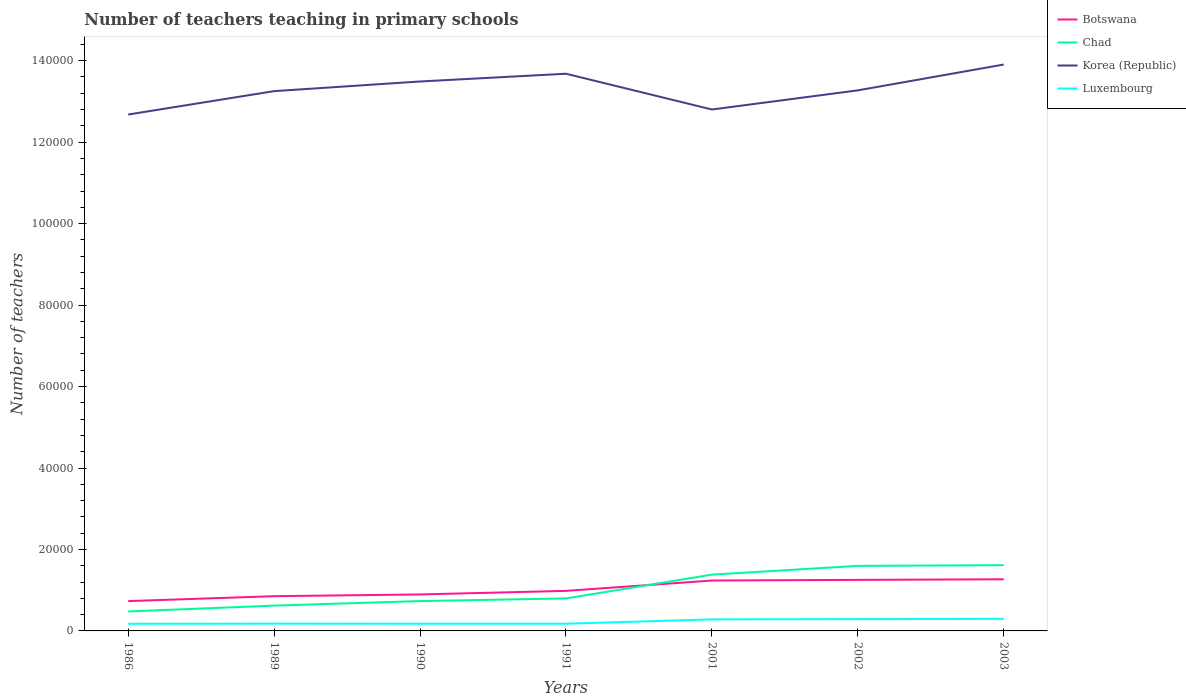How many different coloured lines are there?
Your answer should be compact. 4. Across all years, what is the maximum number of teachers teaching in primary schools in Luxembourg?
Keep it short and to the point. 1745. What is the total number of teachers teaching in primary schools in Korea (Republic) in the graph?
Your answer should be very brief. -2257. What is the difference between the highest and the second highest number of teachers teaching in primary schools in Korea (Republic)?
Ensure brevity in your answer.  1.23e+04. What is the difference between the highest and the lowest number of teachers teaching in primary schools in Korea (Republic)?
Your answer should be very brief. 3. Is the number of teachers teaching in primary schools in Chad strictly greater than the number of teachers teaching in primary schools in Botswana over the years?
Offer a terse response. No. How many years are there in the graph?
Your answer should be very brief. 7. What is the difference between two consecutive major ticks on the Y-axis?
Give a very brief answer. 2.00e+04. Where does the legend appear in the graph?
Make the answer very short. Top right. How many legend labels are there?
Your response must be concise. 4. How are the legend labels stacked?
Ensure brevity in your answer.  Vertical. What is the title of the graph?
Keep it short and to the point. Number of teachers teaching in primary schools. Does "Upper middle income" appear as one of the legend labels in the graph?
Your answer should be very brief. No. What is the label or title of the Y-axis?
Offer a terse response. Number of teachers. What is the Number of teachers in Botswana in 1986?
Offer a terse response. 7324. What is the Number of teachers of Chad in 1986?
Your response must be concise. 4779. What is the Number of teachers of Korea (Republic) in 1986?
Provide a short and direct response. 1.27e+05. What is the Number of teachers of Luxembourg in 1986?
Keep it short and to the point. 1745. What is the Number of teachers in Botswana in 1989?
Your answer should be very brief. 8529. What is the Number of teachers in Chad in 1989?
Offer a terse response. 6215. What is the Number of teachers in Korea (Republic) in 1989?
Give a very brief answer. 1.33e+05. What is the Number of teachers in Luxembourg in 1989?
Provide a succinct answer. 1790. What is the Number of teachers of Botswana in 1990?
Make the answer very short. 8956. What is the Number of teachers of Chad in 1990?
Give a very brief answer. 7327. What is the Number of teachers of Korea (Republic) in 1990?
Your answer should be compact. 1.35e+05. What is the Number of teachers of Luxembourg in 1990?
Keep it short and to the point. 1770. What is the Number of teachers in Botswana in 1991?
Make the answer very short. 9833. What is the Number of teachers in Chad in 1991?
Provide a succinct answer. 7980. What is the Number of teachers in Korea (Republic) in 1991?
Ensure brevity in your answer.  1.37e+05. What is the Number of teachers of Luxembourg in 1991?
Give a very brief answer. 1764. What is the Number of teachers of Botswana in 2001?
Provide a succinct answer. 1.24e+04. What is the Number of teachers of Chad in 2001?
Your response must be concise. 1.38e+04. What is the Number of teachers in Korea (Republic) in 2001?
Offer a very short reply. 1.28e+05. What is the Number of teachers in Luxembourg in 2001?
Your answer should be very brief. 2834. What is the Number of teachers of Botswana in 2002?
Your answer should be very brief. 1.25e+04. What is the Number of teachers in Chad in 2002?
Give a very brief answer. 1.60e+04. What is the Number of teachers of Korea (Republic) in 2002?
Your response must be concise. 1.33e+05. What is the Number of teachers of Luxembourg in 2002?
Offer a very short reply. 2893. What is the Number of teachers in Botswana in 2003?
Make the answer very short. 1.27e+04. What is the Number of teachers of Chad in 2003?
Your answer should be compact. 1.61e+04. What is the Number of teachers in Korea (Republic) in 2003?
Offer a very short reply. 1.39e+05. What is the Number of teachers of Luxembourg in 2003?
Make the answer very short. 2966. Across all years, what is the maximum Number of teachers of Botswana?
Your answer should be very brief. 1.27e+04. Across all years, what is the maximum Number of teachers of Chad?
Give a very brief answer. 1.61e+04. Across all years, what is the maximum Number of teachers in Korea (Republic)?
Your response must be concise. 1.39e+05. Across all years, what is the maximum Number of teachers in Luxembourg?
Keep it short and to the point. 2966. Across all years, what is the minimum Number of teachers in Botswana?
Your answer should be very brief. 7324. Across all years, what is the minimum Number of teachers in Chad?
Give a very brief answer. 4779. Across all years, what is the minimum Number of teachers in Korea (Republic)?
Keep it short and to the point. 1.27e+05. Across all years, what is the minimum Number of teachers of Luxembourg?
Provide a short and direct response. 1745. What is the total Number of teachers of Botswana in the graph?
Provide a succinct answer. 7.22e+04. What is the total Number of teachers of Chad in the graph?
Give a very brief answer. 7.22e+04. What is the total Number of teachers of Korea (Republic) in the graph?
Your answer should be very brief. 9.31e+05. What is the total Number of teachers in Luxembourg in the graph?
Your answer should be compact. 1.58e+04. What is the difference between the Number of teachers of Botswana in 1986 and that in 1989?
Keep it short and to the point. -1205. What is the difference between the Number of teachers in Chad in 1986 and that in 1989?
Your answer should be very brief. -1436. What is the difference between the Number of teachers of Korea (Republic) in 1986 and that in 1989?
Keep it short and to the point. -5742. What is the difference between the Number of teachers in Luxembourg in 1986 and that in 1989?
Keep it short and to the point. -45. What is the difference between the Number of teachers of Botswana in 1986 and that in 1990?
Your response must be concise. -1632. What is the difference between the Number of teachers of Chad in 1986 and that in 1990?
Make the answer very short. -2548. What is the difference between the Number of teachers of Korea (Republic) in 1986 and that in 1990?
Provide a short and direct response. -8113. What is the difference between the Number of teachers of Luxembourg in 1986 and that in 1990?
Your response must be concise. -25. What is the difference between the Number of teachers of Botswana in 1986 and that in 1991?
Provide a short and direct response. -2509. What is the difference between the Number of teachers in Chad in 1986 and that in 1991?
Keep it short and to the point. -3201. What is the difference between the Number of teachers of Korea (Republic) in 1986 and that in 1991?
Provide a succinct answer. -1.00e+04. What is the difference between the Number of teachers of Botswana in 1986 and that in 2001?
Make the answer very short. -5046. What is the difference between the Number of teachers of Chad in 1986 and that in 2001?
Keep it short and to the point. -9040. What is the difference between the Number of teachers of Korea (Republic) in 1986 and that in 2001?
Your answer should be compact. -1233. What is the difference between the Number of teachers of Luxembourg in 1986 and that in 2001?
Your answer should be very brief. -1089. What is the difference between the Number of teachers of Botswana in 1986 and that in 2002?
Your response must be concise. -5207. What is the difference between the Number of teachers of Chad in 1986 and that in 2002?
Offer a very short reply. -1.12e+04. What is the difference between the Number of teachers in Korea (Republic) in 1986 and that in 2002?
Provide a succinct answer. -5931. What is the difference between the Number of teachers of Luxembourg in 1986 and that in 2002?
Provide a succinct answer. -1148. What is the difference between the Number of teachers of Botswana in 1986 and that in 2003?
Offer a terse response. -5354. What is the difference between the Number of teachers of Chad in 1986 and that in 2003?
Your answer should be compact. -1.14e+04. What is the difference between the Number of teachers in Korea (Republic) in 1986 and that in 2003?
Make the answer very short. -1.23e+04. What is the difference between the Number of teachers of Luxembourg in 1986 and that in 2003?
Your answer should be very brief. -1221. What is the difference between the Number of teachers of Botswana in 1989 and that in 1990?
Provide a short and direct response. -427. What is the difference between the Number of teachers in Chad in 1989 and that in 1990?
Your answer should be compact. -1112. What is the difference between the Number of teachers in Korea (Republic) in 1989 and that in 1990?
Offer a very short reply. -2371. What is the difference between the Number of teachers of Botswana in 1989 and that in 1991?
Give a very brief answer. -1304. What is the difference between the Number of teachers in Chad in 1989 and that in 1991?
Offer a very short reply. -1765. What is the difference between the Number of teachers in Korea (Republic) in 1989 and that in 1991?
Your answer should be compact. -4273. What is the difference between the Number of teachers of Botswana in 1989 and that in 2001?
Keep it short and to the point. -3841. What is the difference between the Number of teachers in Chad in 1989 and that in 2001?
Make the answer very short. -7604. What is the difference between the Number of teachers in Korea (Republic) in 1989 and that in 2001?
Keep it short and to the point. 4509. What is the difference between the Number of teachers of Luxembourg in 1989 and that in 2001?
Provide a short and direct response. -1044. What is the difference between the Number of teachers in Botswana in 1989 and that in 2002?
Offer a very short reply. -4002. What is the difference between the Number of teachers in Chad in 1989 and that in 2002?
Give a very brief answer. -9756. What is the difference between the Number of teachers of Korea (Republic) in 1989 and that in 2002?
Offer a terse response. -189. What is the difference between the Number of teachers in Luxembourg in 1989 and that in 2002?
Make the answer very short. -1103. What is the difference between the Number of teachers of Botswana in 1989 and that in 2003?
Your answer should be compact. -4149. What is the difference between the Number of teachers in Chad in 1989 and that in 2003?
Your answer should be very brief. -9927. What is the difference between the Number of teachers in Korea (Republic) in 1989 and that in 2003?
Offer a terse response. -6530. What is the difference between the Number of teachers in Luxembourg in 1989 and that in 2003?
Ensure brevity in your answer.  -1176. What is the difference between the Number of teachers in Botswana in 1990 and that in 1991?
Your answer should be compact. -877. What is the difference between the Number of teachers in Chad in 1990 and that in 1991?
Make the answer very short. -653. What is the difference between the Number of teachers of Korea (Republic) in 1990 and that in 1991?
Offer a very short reply. -1902. What is the difference between the Number of teachers in Luxembourg in 1990 and that in 1991?
Keep it short and to the point. 6. What is the difference between the Number of teachers in Botswana in 1990 and that in 2001?
Your answer should be very brief. -3414. What is the difference between the Number of teachers in Chad in 1990 and that in 2001?
Your answer should be compact. -6492. What is the difference between the Number of teachers in Korea (Republic) in 1990 and that in 2001?
Ensure brevity in your answer.  6880. What is the difference between the Number of teachers of Luxembourg in 1990 and that in 2001?
Ensure brevity in your answer.  -1064. What is the difference between the Number of teachers in Botswana in 1990 and that in 2002?
Your response must be concise. -3575. What is the difference between the Number of teachers of Chad in 1990 and that in 2002?
Your answer should be compact. -8644. What is the difference between the Number of teachers of Korea (Republic) in 1990 and that in 2002?
Provide a short and direct response. 2182. What is the difference between the Number of teachers in Luxembourg in 1990 and that in 2002?
Provide a succinct answer. -1123. What is the difference between the Number of teachers in Botswana in 1990 and that in 2003?
Make the answer very short. -3722. What is the difference between the Number of teachers of Chad in 1990 and that in 2003?
Provide a succinct answer. -8815. What is the difference between the Number of teachers in Korea (Republic) in 1990 and that in 2003?
Offer a very short reply. -4159. What is the difference between the Number of teachers of Luxembourg in 1990 and that in 2003?
Give a very brief answer. -1196. What is the difference between the Number of teachers of Botswana in 1991 and that in 2001?
Offer a terse response. -2537. What is the difference between the Number of teachers of Chad in 1991 and that in 2001?
Keep it short and to the point. -5839. What is the difference between the Number of teachers of Korea (Republic) in 1991 and that in 2001?
Provide a short and direct response. 8782. What is the difference between the Number of teachers of Luxembourg in 1991 and that in 2001?
Ensure brevity in your answer.  -1070. What is the difference between the Number of teachers in Botswana in 1991 and that in 2002?
Provide a succinct answer. -2698. What is the difference between the Number of teachers in Chad in 1991 and that in 2002?
Make the answer very short. -7991. What is the difference between the Number of teachers of Korea (Republic) in 1991 and that in 2002?
Your answer should be very brief. 4084. What is the difference between the Number of teachers in Luxembourg in 1991 and that in 2002?
Keep it short and to the point. -1129. What is the difference between the Number of teachers in Botswana in 1991 and that in 2003?
Your response must be concise. -2845. What is the difference between the Number of teachers in Chad in 1991 and that in 2003?
Your response must be concise. -8162. What is the difference between the Number of teachers in Korea (Republic) in 1991 and that in 2003?
Offer a very short reply. -2257. What is the difference between the Number of teachers of Luxembourg in 1991 and that in 2003?
Offer a terse response. -1202. What is the difference between the Number of teachers in Botswana in 2001 and that in 2002?
Make the answer very short. -161. What is the difference between the Number of teachers of Chad in 2001 and that in 2002?
Give a very brief answer. -2152. What is the difference between the Number of teachers in Korea (Republic) in 2001 and that in 2002?
Offer a very short reply. -4698. What is the difference between the Number of teachers of Luxembourg in 2001 and that in 2002?
Make the answer very short. -59. What is the difference between the Number of teachers in Botswana in 2001 and that in 2003?
Ensure brevity in your answer.  -308. What is the difference between the Number of teachers in Chad in 2001 and that in 2003?
Offer a very short reply. -2323. What is the difference between the Number of teachers in Korea (Republic) in 2001 and that in 2003?
Your response must be concise. -1.10e+04. What is the difference between the Number of teachers in Luxembourg in 2001 and that in 2003?
Make the answer very short. -132. What is the difference between the Number of teachers in Botswana in 2002 and that in 2003?
Give a very brief answer. -147. What is the difference between the Number of teachers of Chad in 2002 and that in 2003?
Make the answer very short. -171. What is the difference between the Number of teachers in Korea (Republic) in 2002 and that in 2003?
Your answer should be very brief. -6341. What is the difference between the Number of teachers of Luxembourg in 2002 and that in 2003?
Provide a succinct answer. -73. What is the difference between the Number of teachers of Botswana in 1986 and the Number of teachers of Chad in 1989?
Provide a short and direct response. 1109. What is the difference between the Number of teachers in Botswana in 1986 and the Number of teachers in Korea (Republic) in 1989?
Provide a succinct answer. -1.25e+05. What is the difference between the Number of teachers of Botswana in 1986 and the Number of teachers of Luxembourg in 1989?
Provide a succinct answer. 5534. What is the difference between the Number of teachers in Chad in 1986 and the Number of teachers in Korea (Republic) in 1989?
Provide a succinct answer. -1.28e+05. What is the difference between the Number of teachers of Chad in 1986 and the Number of teachers of Luxembourg in 1989?
Offer a very short reply. 2989. What is the difference between the Number of teachers of Korea (Republic) in 1986 and the Number of teachers of Luxembourg in 1989?
Offer a very short reply. 1.25e+05. What is the difference between the Number of teachers in Botswana in 1986 and the Number of teachers in Chad in 1990?
Keep it short and to the point. -3. What is the difference between the Number of teachers of Botswana in 1986 and the Number of teachers of Korea (Republic) in 1990?
Your response must be concise. -1.28e+05. What is the difference between the Number of teachers of Botswana in 1986 and the Number of teachers of Luxembourg in 1990?
Keep it short and to the point. 5554. What is the difference between the Number of teachers of Chad in 1986 and the Number of teachers of Korea (Republic) in 1990?
Offer a terse response. -1.30e+05. What is the difference between the Number of teachers of Chad in 1986 and the Number of teachers of Luxembourg in 1990?
Ensure brevity in your answer.  3009. What is the difference between the Number of teachers of Korea (Republic) in 1986 and the Number of teachers of Luxembourg in 1990?
Make the answer very short. 1.25e+05. What is the difference between the Number of teachers in Botswana in 1986 and the Number of teachers in Chad in 1991?
Ensure brevity in your answer.  -656. What is the difference between the Number of teachers of Botswana in 1986 and the Number of teachers of Korea (Republic) in 1991?
Provide a short and direct response. -1.29e+05. What is the difference between the Number of teachers of Botswana in 1986 and the Number of teachers of Luxembourg in 1991?
Offer a terse response. 5560. What is the difference between the Number of teachers in Chad in 1986 and the Number of teachers in Korea (Republic) in 1991?
Provide a succinct answer. -1.32e+05. What is the difference between the Number of teachers of Chad in 1986 and the Number of teachers of Luxembourg in 1991?
Ensure brevity in your answer.  3015. What is the difference between the Number of teachers of Korea (Republic) in 1986 and the Number of teachers of Luxembourg in 1991?
Your answer should be very brief. 1.25e+05. What is the difference between the Number of teachers in Botswana in 1986 and the Number of teachers in Chad in 2001?
Your answer should be very brief. -6495. What is the difference between the Number of teachers in Botswana in 1986 and the Number of teachers in Korea (Republic) in 2001?
Provide a short and direct response. -1.21e+05. What is the difference between the Number of teachers in Botswana in 1986 and the Number of teachers in Luxembourg in 2001?
Offer a terse response. 4490. What is the difference between the Number of teachers of Chad in 1986 and the Number of teachers of Korea (Republic) in 2001?
Give a very brief answer. -1.23e+05. What is the difference between the Number of teachers of Chad in 1986 and the Number of teachers of Luxembourg in 2001?
Offer a very short reply. 1945. What is the difference between the Number of teachers of Korea (Republic) in 1986 and the Number of teachers of Luxembourg in 2001?
Keep it short and to the point. 1.24e+05. What is the difference between the Number of teachers in Botswana in 1986 and the Number of teachers in Chad in 2002?
Keep it short and to the point. -8647. What is the difference between the Number of teachers in Botswana in 1986 and the Number of teachers in Korea (Republic) in 2002?
Make the answer very short. -1.25e+05. What is the difference between the Number of teachers in Botswana in 1986 and the Number of teachers in Luxembourg in 2002?
Ensure brevity in your answer.  4431. What is the difference between the Number of teachers in Chad in 1986 and the Number of teachers in Korea (Republic) in 2002?
Provide a succinct answer. -1.28e+05. What is the difference between the Number of teachers in Chad in 1986 and the Number of teachers in Luxembourg in 2002?
Your answer should be compact. 1886. What is the difference between the Number of teachers in Korea (Republic) in 1986 and the Number of teachers in Luxembourg in 2002?
Your answer should be very brief. 1.24e+05. What is the difference between the Number of teachers in Botswana in 1986 and the Number of teachers in Chad in 2003?
Provide a short and direct response. -8818. What is the difference between the Number of teachers in Botswana in 1986 and the Number of teachers in Korea (Republic) in 2003?
Offer a terse response. -1.32e+05. What is the difference between the Number of teachers in Botswana in 1986 and the Number of teachers in Luxembourg in 2003?
Offer a very short reply. 4358. What is the difference between the Number of teachers in Chad in 1986 and the Number of teachers in Korea (Republic) in 2003?
Your answer should be compact. -1.34e+05. What is the difference between the Number of teachers of Chad in 1986 and the Number of teachers of Luxembourg in 2003?
Provide a succinct answer. 1813. What is the difference between the Number of teachers in Korea (Republic) in 1986 and the Number of teachers in Luxembourg in 2003?
Provide a succinct answer. 1.24e+05. What is the difference between the Number of teachers of Botswana in 1989 and the Number of teachers of Chad in 1990?
Keep it short and to the point. 1202. What is the difference between the Number of teachers of Botswana in 1989 and the Number of teachers of Korea (Republic) in 1990?
Offer a terse response. -1.26e+05. What is the difference between the Number of teachers in Botswana in 1989 and the Number of teachers in Luxembourg in 1990?
Your answer should be very brief. 6759. What is the difference between the Number of teachers in Chad in 1989 and the Number of teachers in Korea (Republic) in 1990?
Keep it short and to the point. -1.29e+05. What is the difference between the Number of teachers of Chad in 1989 and the Number of teachers of Luxembourg in 1990?
Provide a succinct answer. 4445. What is the difference between the Number of teachers of Korea (Republic) in 1989 and the Number of teachers of Luxembourg in 1990?
Make the answer very short. 1.31e+05. What is the difference between the Number of teachers in Botswana in 1989 and the Number of teachers in Chad in 1991?
Ensure brevity in your answer.  549. What is the difference between the Number of teachers of Botswana in 1989 and the Number of teachers of Korea (Republic) in 1991?
Keep it short and to the point. -1.28e+05. What is the difference between the Number of teachers of Botswana in 1989 and the Number of teachers of Luxembourg in 1991?
Provide a succinct answer. 6765. What is the difference between the Number of teachers in Chad in 1989 and the Number of teachers in Korea (Republic) in 1991?
Give a very brief answer. -1.31e+05. What is the difference between the Number of teachers of Chad in 1989 and the Number of teachers of Luxembourg in 1991?
Your answer should be very brief. 4451. What is the difference between the Number of teachers of Korea (Republic) in 1989 and the Number of teachers of Luxembourg in 1991?
Provide a succinct answer. 1.31e+05. What is the difference between the Number of teachers of Botswana in 1989 and the Number of teachers of Chad in 2001?
Give a very brief answer. -5290. What is the difference between the Number of teachers in Botswana in 1989 and the Number of teachers in Korea (Republic) in 2001?
Offer a very short reply. -1.19e+05. What is the difference between the Number of teachers of Botswana in 1989 and the Number of teachers of Luxembourg in 2001?
Provide a short and direct response. 5695. What is the difference between the Number of teachers in Chad in 1989 and the Number of teachers in Korea (Republic) in 2001?
Provide a succinct answer. -1.22e+05. What is the difference between the Number of teachers in Chad in 1989 and the Number of teachers in Luxembourg in 2001?
Provide a short and direct response. 3381. What is the difference between the Number of teachers in Korea (Republic) in 1989 and the Number of teachers in Luxembourg in 2001?
Provide a short and direct response. 1.30e+05. What is the difference between the Number of teachers of Botswana in 1989 and the Number of teachers of Chad in 2002?
Your answer should be very brief. -7442. What is the difference between the Number of teachers in Botswana in 1989 and the Number of teachers in Korea (Republic) in 2002?
Your answer should be compact. -1.24e+05. What is the difference between the Number of teachers in Botswana in 1989 and the Number of teachers in Luxembourg in 2002?
Provide a succinct answer. 5636. What is the difference between the Number of teachers in Chad in 1989 and the Number of teachers in Korea (Republic) in 2002?
Give a very brief answer. -1.27e+05. What is the difference between the Number of teachers of Chad in 1989 and the Number of teachers of Luxembourg in 2002?
Keep it short and to the point. 3322. What is the difference between the Number of teachers of Korea (Republic) in 1989 and the Number of teachers of Luxembourg in 2002?
Your response must be concise. 1.30e+05. What is the difference between the Number of teachers of Botswana in 1989 and the Number of teachers of Chad in 2003?
Your answer should be compact. -7613. What is the difference between the Number of teachers of Botswana in 1989 and the Number of teachers of Korea (Republic) in 2003?
Give a very brief answer. -1.31e+05. What is the difference between the Number of teachers of Botswana in 1989 and the Number of teachers of Luxembourg in 2003?
Provide a short and direct response. 5563. What is the difference between the Number of teachers of Chad in 1989 and the Number of teachers of Korea (Republic) in 2003?
Keep it short and to the point. -1.33e+05. What is the difference between the Number of teachers in Chad in 1989 and the Number of teachers in Luxembourg in 2003?
Ensure brevity in your answer.  3249. What is the difference between the Number of teachers in Korea (Republic) in 1989 and the Number of teachers in Luxembourg in 2003?
Keep it short and to the point. 1.30e+05. What is the difference between the Number of teachers in Botswana in 1990 and the Number of teachers in Chad in 1991?
Provide a short and direct response. 976. What is the difference between the Number of teachers in Botswana in 1990 and the Number of teachers in Korea (Republic) in 1991?
Provide a short and direct response. -1.28e+05. What is the difference between the Number of teachers in Botswana in 1990 and the Number of teachers in Luxembourg in 1991?
Offer a terse response. 7192. What is the difference between the Number of teachers in Chad in 1990 and the Number of teachers in Korea (Republic) in 1991?
Make the answer very short. -1.29e+05. What is the difference between the Number of teachers in Chad in 1990 and the Number of teachers in Luxembourg in 1991?
Ensure brevity in your answer.  5563. What is the difference between the Number of teachers in Korea (Republic) in 1990 and the Number of teachers in Luxembourg in 1991?
Provide a succinct answer. 1.33e+05. What is the difference between the Number of teachers of Botswana in 1990 and the Number of teachers of Chad in 2001?
Your response must be concise. -4863. What is the difference between the Number of teachers of Botswana in 1990 and the Number of teachers of Korea (Republic) in 2001?
Provide a succinct answer. -1.19e+05. What is the difference between the Number of teachers in Botswana in 1990 and the Number of teachers in Luxembourg in 2001?
Make the answer very short. 6122. What is the difference between the Number of teachers in Chad in 1990 and the Number of teachers in Korea (Republic) in 2001?
Provide a short and direct response. -1.21e+05. What is the difference between the Number of teachers in Chad in 1990 and the Number of teachers in Luxembourg in 2001?
Keep it short and to the point. 4493. What is the difference between the Number of teachers of Korea (Republic) in 1990 and the Number of teachers of Luxembourg in 2001?
Your answer should be compact. 1.32e+05. What is the difference between the Number of teachers of Botswana in 1990 and the Number of teachers of Chad in 2002?
Keep it short and to the point. -7015. What is the difference between the Number of teachers in Botswana in 1990 and the Number of teachers in Korea (Republic) in 2002?
Give a very brief answer. -1.24e+05. What is the difference between the Number of teachers in Botswana in 1990 and the Number of teachers in Luxembourg in 2002?
Ensure brevity in your answer.  6063. What is the difference between the Number of teachers in Chad in 1990 and the Number of teachers in Korea (Republic) in 2002?
Ensure brevity in your answer.  -1.25e+05. What is the difference between the Number of teachers of Chad in 1990 and the Number of teachers of Luxembourg in 2002?
Provide a short and direct response. 4434. What is the difference between the Number of teachers of Korea (Republic) in 1990 and the Number of teachers of Luxembourg in 2002?
Give a very brief answer. 1.32e+05. What is the difference between the Number of teachers in Botswana in 1990 and the Number of teachers in Chad in 2003?
Provide a succinct answer. -7186. What is the difference between the Number of teachers of Botswana in 1990 and the Number of teachers of Korea (Republic) in 2003?
Offer a very short reply. -1.30e+05. What is the difference between the Number of teachers in Botswana in 1990 and the Number of teachers in Luxembourg in 2003?
Give a very brief answer. 5990. What is the difference between the Number of teachers in Chad in 1990 and the Number of teachers in Korea (Republic) in 2003?
Offer a terse response. -1.32e+05. What is the difference between the Number of teachers of Chad in 1990 and the Number of teachers of Luxembourg in 2003?
Your answer should be compact. 4361. What is the difference between the Number of teachers of Korea (Republic) in 1990 and the Number of teachers of Luxembourg in 2003?
Your answer should be compact. 1.32e+05. What is the difference between the Number of teachers of Botswana in 1991 and the Number of teachers of Chad in 2001?
Keep it short and to the point. -3986. What is the difference between the Number of teachers in Botswana in 1991 and the Number of teachers in Korea (Republic) in 2001?
Make the answer very short. -1.18e+05. What is the difference between the Number of teachers of Botswana in 1991 and the Number of teachers of Luxembourg in 2001?
Provide a short and direct response. 6999. What is the difference between the Number of teachers of Chad in 1991 and the Number of teachers of Korea (Republic) in 2001?
Provide a short and direct response. -1.20e+05. What is the difference between the Number of teachers in Chad in 1991 and the Number of teachers in Luxembourg in 2001?
Ensure brevity in your answer.  5146. What is the difference between the Number of teachers in Korea (Republic) in 1991 and the Number of teachers in Luxembourg in 2001?
Make the answer very short. 1.34e+05. What is the difference between the Number of teachers of Botswana in 1991 and the Number of teachers of Chad in 2002?
Your response must be concise. -6138. What is the difference between the Number of teachers in Botswana in 1991 and the Number of teachers in Korea (Republic) in 2002?
Your answer should be very brief. -1.23e+05. What is the difference between the Number of teachers in Botswana in 1991 and the Number of teachers in Luxembourg in 2002?
Provide a succinct answer. 6940. What is the difference between the Number of teachers of Chad in 1991 and the Number of teachers of Korea (Republic) in 2002?
Provide a short and direct response. -1.25e+05. What is the difference between the Number of teachers in Chad in 1991 and the Number of teachers in Luxembourg in 2002?
Make the answer very short. 5087. What is the difference between the Number of teachers of Korea (Republic) in 1991 and the Number of teachers of Luxembourg in 2002?
Offer a terse response. 1.34e+05. What is the difference between the Number of teachers in Botswana in 1991 and the Number of teachers in Chad in 2003?
Your answer should be very brief. -6309. What is the difference between the Number of teachers of Botswana in 1991 and the Number of teachers of Korea (Republic) in 2003?
Ensure brevity in your answer.  -1.29e+05. What is the difference between the Number of teachers of Botswana in 1991 and the Number of teachers of Luxembourg in 2003?
Your answer should be compact. 6867. What is the difference between the Number of teachers of Chad in 1991 and the Number of teachers of Korea (Republic) in 2003?
Offer a terse response. -1.31e+05. What is the difference between the Number of teachers in Chad in 1991 and the Number of teachers in Luxembourg in 2003?
Give a very brief answer. 5014. What is the difference between the Number of teachers in Korea (Republic) in 1991 and the Number of teachers in Luxembourg in 2003?
Offer a very short reply. 1.34e+05. What is the difference between the Number of teachers of Botswana in 2001 and the Number of teachers of Chad in 2002?
Your answer should be very brief. -3601. What is the difference between the Number of teachers in Botswana in 2001 and the Number of teachers in Korea (Republic) in 2002?
Provide a short and direct response. -1.20e+05. What is the difference between the Number of teachers in Botswana in 2001 and the Number of teachers in Luxembourg in 2002?
Give a very brief answer. 9477. What is the difference between the Number of teachers of Chad in 2001 and the Number of teachers of Korea (Republic) in 2002?
Provide a short and direct response. -1.19e+05. What is the difference between the Number of teachers in Chad in 2001 and the Number of teachers in Luxembourg in 2002?
Offer a terse response. 1.09e+04. What is the difference between the Number of teachers in Korea (Republic) in 2001 and the Number of teachers in Luxembourg in 2002?
Keep it short and to the point. 1.25e+05. What is the difference between the Number of teachers in Botswana in 2001 and the Number of teachers in Chad in 2003?
Your answer should be compact. -3772. What is the difference between the Number of teachers in Botswana in 2001 and the Number of teachers in Korea (Republic) in 2003?
Provide a succinct answer. -1.27e+05. What is the difference between the Number of teachers in Botswana in 2001 and the Number of teachers in Luxembourg in 2003?
Offer a very short reply. 9404. What is the difference between the Number of teachers in Chad in 2001 and the Number of teachers in Korea (Republic) in 2003?
Give a very brief answer. -1.25e+05. What is the difference between the Number of teachers of Chad in 2001 and the Number of teachers of Luxembourg in 2003?
Ensure brevity in your answer.  1.09e+04. What is the difference between the Number of teachers of Korea (Republic) in 2001 and the Number of teachers of Luxembourg in 2003?
Keep it short and to the point. 1.25e+05. What is the difference between the Number of teachers of Botswana in 2002 and the Number of teachers of Chad in 2003?
Keep it short and to the point. -3611. What is the difference between the Number of teachers in Botswana in 2002 and the Number of teachers in Korea (Republic) in 2003?
Offer a very short reply. -1.27e+05. What is the difference between the Number of teachers of Botswana in 2002 and the Number of teachers of Luxembourg in 2003?
Your answer should be very brief. 9565. What is the difference between the Number of teachers of Chad in 2002 and the Number of teachers of Korea (Republic) in 2003?
Offer a terse response. -1.23e+05. What is the difference between the Number of teachers of Chad in 2002 and the Number of teachers of Luxembourg in 2003?
Your answer should be compact. 1.30e+04. What is the difference between the Number of teachers in Korea (Republic) in 2002 and the Number of teachers in Luxembourg in 2003?
Provide a short and direct response. 1.30e+05. What is the average Number of teachers in Botswana per year?
Your answer should be very brief. 1.03e+04. What is the average Number of teachers of Chad per year?
Your answer should be compact. 1.03e+04. What is the average Number of teachers of Korea (Republic) per year?
Provide a succinct answer. 1.33e+05. What is the average Number of teachers in Luxembourg per year?
Your answer should be very brief. 2251.71. In the year 1986, what is the difference between the Number of teachers in Botswana and Number of teachers in Chad?
Your response must be concise. 2545. In the year 1986, what is the difference between the Number of teachers of Botswana and Number of teachers of Korea (Republic)?
Provide a short and direct response. -1.19e+05. In the year 1986, what is the difference between the Number of teachers of Botswana and Number of teachers of Luxembourg?
Provide a succinct answer. 5579. In the year 1986, what is the difference between the Number of teachers of Chad and Number of teachers of Korea (Republic)?
Make the answer very short. -1.22e+05. In the year 1986, what is the difference between the Number of teachers in Chad and Number of teachers in Luxembourg?
Give a very brief answer. 3034. In the year 1986, what is the difference between the Number of teachers of Korea (Republic) and Number of teachers of Luxembourg?
Offer a very short reply. 1.25e+05. In the year 1989, what is the difference between the Number of teachers of Botswana and Number of teachers of Chad?
Your response must be concise. 2314. In the year 1989, what is the difference between the Number of teachers of Botswana and Number of teachers of Korea (Republic)?
Make the answer very short. -1.24e+05. In the year 1989, what is the difference between the Number of teachers of Botswana and Number of teachers of Luxembourg?
Offer a terse response. 6739. In the year 1989, what is the difference between the Number of teachers in Chad and Number of teachers in Korea (Republic)?
Make the answer very short. -1.26e+05. In the year 1989, what is the difference between the Number of teachers of Chad and Number of teachers of Luxembourg?
Offer a terse response. 4425. In the year 1989, what is the difference between the Number of teachers of Korea (Republic) and Number of teachers of Luxembourg?
Make the answer very short. 1.31e+05. In the year 1990, what is the difference between the Number of teachers of Botswana and Number of teachers of Chad?
Offer a terse response. 1629. In the year 1990, what is the difference between the Number of teachers in Botswana and Number of teachers in Korea (Republic)?
Provide a succinct answer. -1.26e+05. In the year 1990, what is the difference between the Number of teachers in Botswana and Number of teachers in Luxembourg?
Ensure brevity in your answer.  7186. In the year 1990, what is the difference between the Number of teachers in Chad and Number of teachers in Korea (Republic)?
Your response must be concise. -1.28e+05. In the year 1990, what is the difference between the Number of teachers in Chad and Number of teachers in Luxembourg?
Keep it short and to the point. 5557. In the year 1990, what is the difference between the Number of teachers of Korea (Republic) and Number of teachers of Luxembourg?
Keep it short and to the point. 1.33e+05. In the year 1991, what is the difference between the Number of teachers in Botswana and Number of teachers in Chad?
Make the answer very short. 1853. In the year 1991, what is the difference between the Number of teachers in Botswana and Number of teachers in Korea (Republic)?
Give a very brief answer. -1.27e+05. In the year 1991, what is the difference between the Number of teachers of Botswana and Number of teachers of Luxembourg?
Your answer should be very brief. 8069. In the year 1991, what is the difference between the Number of teachers in Chad and Number of teachers in Korea (Republic)?
Offer a terse response. -1.29e+05. In the year 1991, what is the difference between the Number of teachers in Chad and Number of teachers in Luxembourg?
Make the answer very short. 6216. In the year 1991, what is the difference between the Number of teachers in Korea (Republic) and Number of teachers in Luxembourg?
Make the answer very short. 1.35e+05. In the year 2001, what is the difference between the Number of teachers in Botswana and Number of teachers in Chad?
Offer a terse response. -1449. In the year 2001, what is the difference between the Number of teachers in Botswana and Number of teachers in Korea (Republic)?
Make the answer very short. -1.16e+05. In the year 2001, what is the difference between the Number of teachers of Botswana and Number of teachers of Luxembourg?
Provide a short and direct response. 9536. In the year 2001, what is the difference between the Number of teachers in Chad and Number of teachers in Korea (Republic)?
Offer a terse response. -1.14e+05. In the year 2001, what is the difference between the Number of teachers in Chad and Number of teachers in Luxembourg?
Make the answer very short. 1.10e+04. In the year 2001, what is the difference between the Number of teachers of Korea (Republic) and Number of teachers of Luxembourg?
Your answer should be compact. 1.25e+05. In the year 2002, what is the difference between the Number of teachers of Botswana and Number of teachers of Chad?
Give a very brief answer. -3440. In the year 2002, what is the difference between the Number of teachers in Botswana and Number of teachers in Korea (Republic)?
Your answer should be very brief. -1.20e+05. In the year 2002, what is the difference between the Number of teachers in Botswana and Number of teachers in Luxembourg?
Your answer should be compact. 9638. In the year 2002, what is the difference between the Number of teachers in Chad and Number of teachers in Korea (Republic)?
Offer a very short reply. -1.17e+05. In the year 2002, what is the difference between the Number of teachers in Chad and Number of teachers in Luxembourg?
Offer a terse response. 1.31e+04. In the year 2002, what is the difference between the Number of teachers of Korea (Republic) and Number of teachers of Luxembourg?
Offer a terse response. 1.30e+05. In the year 2003, what is the difference between the Number of teachers of Botswana and Number of teachers of Chad?
Make the answer very short. -3464. In the year 2003, what is the difference between the Number of teachers of Botswana and Number of teachers of Korea (Republic)?
Provide a succinct answer. -1.26e+05. In the year 2003, what is the difference between the Number of teachers in Botswana and Number of teachers in Luxembourg?
Keep it short and to the point. 9712. In the year 2003, what is the difference between the Number of teachers of Chad and Number of teachers of Korea (Republic)?
Offer a terse response. -1.23e+05. In the year 2003, what is the difference between the Number of teachers of Chad and Number of teachers of Luxembourg?
Keep it short and to the point. 1.32e+04. In the year 2003, what is the difference between the Number of teachers in Korea (Republic) and Number of teachers in Luxembourg?
Your answer should be compact. 1.36e+05. What is the ratio of the Number of teachers in Botswana in 1986 to that in 1989?
Provide a succinct answer. 0.86. What is the ratio of the Number of teachers in Chad in 1986 to that in 1989?
Offer a very short reply. 0.77. What is the ratio of the Number of teachers in Korea (Republic) in 1986 to that in 1989?
Provide a short and direct response. 0.96. What is the ratio of the Number of teachers in Luxembourg in 1986 to that in 1989?
Your answer should be very brief. 0.97. What is the ratio of the Number of teachers of Botswana in 1986 to that in 1990?
Offer a very short reply. 0.82. What is the ratio of the Number of teachers of Chad in 1986 to that in 1990?
Provide a short and direct response. 0.65. What is the ratio of the Number of teachers in Korea (Republic) in 1986 to that in 1990?
Ensure brevity in your answer.  0.94. What is the ratio of the Number of teachers of Luxembourg in 1986 to that in 1990?
Ensure brevity in your answer.  0.99. What is the ratio of the Number of teachers of Botswana in 1986 to that in 1991?
Your answer should be very brief. 0.74. What is the ratio of the Number of teachers of Chad in 1986 to that in 1991?
Your response must be concise. 0.6. What is the ratio of the Number of teachers of Korea (Republic) in 1986 to that in 1991?
Keep it short and to the point. 0.93. What is the ratio of the Number of teachers in Luxembourg in 1986 to that in 1991?
Keep it short and to the point. 0.99. What is the ratio of the Number of teachers in Botswana in 1986 to that in 2001?
Keep it short and to the point. 0.59. What is the ratio of the Number of teachers in Chad in 1986 to that in 2001?
Provide a succinct answer. 0.35. What is the ratio of the Number of teachers of Luxembourg in 1986 to that in 2001?
Your response must be concise. 0.62. What is the ratio of the Number of teachers in Botswana in 1986 to that in 2002?
Your answer should be very brief. 0.58. What is the ratio of the Number of teachers of Chad in 1986 to that in 2002?
Provide a succinct answer. 0.3. What is the ratio of the Number of teachers of Korea (Republic) in 1986 to that in 2002?
Your answer should be compact. 0.96. What is the ratio of the Number of teachers in Luxembourg in 1986 to that in 2002?
Make the answer very short. 0.6. What is the ratio of the Number of teachers in Botswana in 1986 to that in 2003?
Make the answer very short. 0.58. What is the ratio of the Number of teachers in Chad in 1986 to that in 2003?
Provide a succinct answer. 0.3. What is the ratio of the Number of teachers of Korea (Republic) in 1986 to that in 2003?
Offer a terse response. 0.91. What is the ratio of the Number of teachers in Luxembourg in 1986 to that in 2003?
Provide a short and direct response. 0.59. What is the ratio of the Number of teachers of Botswana in 1989 to that in 1990?
Provide a short and direct response. 0.95. What is the ratio of the Number of teachers in Chad in 1989 to that in 1990?
Provide a succinct answer. 0.85. What is the ratio of the Number of teachers of Korea (Republic) in 1989 to that in 1990?
Ensure brevity in your answer.  0.98. What is the ratio of the Number of teachers of Luxembourg in 1989 to that in 1990?
Keep it short and to the point. 1.01. What is the ratio of the Number of teachers of Botswana in 1989 to that in 1991?
Your response must be concise. 0.87. What is the ratio of the Number of teachers in Chad in 1989 to that in 1991?
Your answer should be very brief. 0.78. What is the ratio of the Number of teachers of Korea (Republic) in 1989 to that in 1991?
Ensure brevity in your answer.  0.97. What is the ratio of the Number of teachers of Luxembourg in 1989 to that in 1991?
Your answer should be compact. 1.01. What is the ratio of the Number of teachers of Botswana in 1989 to that in 2001?
Keep it short and to the point. 0.69. What is the ratio of the Number of teachers of Chad in 1989 to that in 2001?
Offer a very short reply. 0.45. What is the ratio of the Number of teachers in Korea (Republic) in 1989 to that in 2001?
Provide a short and direct response. 1.04. What is the ratio of the Number of teachers in Luxembourg in 1989 to that in 2001?
Give a very brief answer. 0.63. What is the ratio of the Number of teachers of Botswana in 1989 to that in 2002?
Offer a terse response. 0.68. What is the ratio of the Number of teachers of Chad in 1989 to that in 2002?
Ensure brevity in your answer.  0.39. What is the ratio of the Number of teachers of Korea (Republic) in 1989 to that in 2002?
Your answer should be compact. 1. What is the ratio of the Number of teachers in Luxembourg in 1989 to that in 2002?
Keep it short and to the point. 0.62. What is the ratio of the Number of teachers in Botswana in 1989 to that in 2003?
Offer a terse response. 0.67. What is the ratio of the Number of teachers in Chad in 1989 to that in 2003?
Give a very brief answer. 0.39. What is the ratio of the Number of teachers of Korea (Republic) in 1989 to that in 2003?
Give a very brief answer. 0.95. What is the ratio of the Number of teachers of Luxembourg in 1989 to that in 2003?
Offer a very short reply. 0.6. What is the ratio of the Number of teachers of Botswana in 1990 to that in 1991?
Offer a very short reply. 0.91. What is the ratio of the Number of teachers in Chad in 1990 to that in 1991?
Keep it short and to the point. 0.92. What is the ratio of the Number of teachers in Korea (Republic) in 1990 to that in 1991?
Ensure brevity in your answer.  0.99. What is the ratio of the Number of teachers of Luxembourg in 1990 to that in 1991?
Give a very brief answer. 1. What is the ratio of the Number of teachers in Botswana in 1990 to that in 2001?
Your response must be concise. 0.72. What is the ratio of the Number of teachers of Chad in 1990 to that in 2001?
Provide a short and direct response. 0.53. What is the ratio of the Number of teachers of Korea (Republic) in 1990 to that in 2001?
Your answer should be very brief. 1.05. What is the ratio of the Number of teachers in Luxembourg in 1990 to that in 2001?
Give a very brief answer. 0.62. What is the ratio of the Number of teachers in Botswana in 1990 to that in 2002?
Offer a terse response. 0.71. What is the ratio of the Number of teachers of Chad in 1990 to that in 2002?
Provide a short and direct response. 0.46. What is the ratio of the Number of teachers in Korea (Republic) in 1990 to that in 2002?
Your answer should be compact. 1.02. What is the ratio of the Number of teachers of Luxembourg in 1990 to that in 2002?
Offer a very short reply. 0.61. What is the ratio of the Number of teachers of Botswana in 1990 to that in 2003?
Give a very brief answer. 0.71. What is the ratio of the Number of teachers in Chad in 1990 to that in 2003?
Your answer should be compact. 0.45. What is the ratio of the Number of teachers in Korea (Republic) in 1990 to that in 2003?
Keep it short and to the point. 0.97. What is the ratio of the Number of teachers in Luxembourg in 1990 to that in 2003?
Ensure brevity in your answer.  0.6. What is the ratio of the Number of teachers in Botswana in 1991 to that in 2001?
Provide a short and direct response. 0.79. What is the ratio of the Number of teachers in Chad in 1991 to that in 2001?
Ensure brevity in your answer.  0.58. What is the ratio of the Number of teachers of Korea (Republic) in 1991 to that in 2001?
Provide a short and direct response. 1.07. What is the ratio of the Number of teachers in Luxembourg in 1991 to that in 2001?
Offer a terse response. 0.62. What is the ratio of the Number of teachers of Botswana in 1991 to that in 2002?
Your response must be concise. 0.78. What is the ratio of the Number of teachers in Chad in 1991 to that in 2002?
Make the answer very short. 0.5. What is the ratio of the Number of teachers in Korea (Republic) in 1991 to that in 2002?
Provide a succinct answer. 1.03. What is the ratio of the Number of teachers of Luxembourg in 1991 to that in 2002?
Make the answer very short. 0.61. What is the ratio of the Number of teachers in Botswana in 1991 to that in 2003?
Your response must be concise. 0.78. What is the ratio of the Number of teachers of Chad in 1991 to that in 2003?
Give a very brief answer. 0.49. What is the ratio of the Number of teachers in Korea (Republic) in 1991 to that in 2003?
Your response must be concise. 0.98. What is the ratio of the Number of teachers in Luxembourg in 1991 to that in 2003?
Your response must be concise. 0.59. What is the ratio of the Number of teachers of Botswana in 2001 to that in 2002?
Offer a very short reply. 0.99. What is the ratio of the Number of teachers of Chad in 2001 to that in 2002?
Offer a terse response. 0.87. What is the ratio of the Number of teachers in Korea (Republic) in 2001 to that in 2002?
Make the answer very short. 0.96. What is the ratio of the Number of teachers of Luxembourg in 2001 to that in 2002?
Keep it short and to the point. 0.98. What is the ratio of the Number of teachers in Botswana in 2001 to that in 2003?
Ensure brevity in your answer.  0.98. What is the ratio of the Number of teachers of Chad in 2001 to that in 2003?
Make the answer very short. 0.86. What is the ratio of the Number of teachers in Korea (Republic) in 2001 to that in 2003?
Offer a very short reply. 0.92. What is the ratio of the Number of teachers of Luxembourg in 2001 to that in 2003?
Your response must be concise. 0.96. What is the ratio of the Number of teachers of Botswana in 2002 to that in 2003?
Offer a terse response. 0.99. What is the ratio of the Number of teachers of Chad in 2002 to that in 2003?
Keep it short and to the point. 0.99. What is the ratio of the Number of teachers in Korea (Republic) in 2002 to that in 2003?
Your answer should be very brief. 0.95. What is the ratio of the Number of teachers in Luxembourg in 2002 to that in 2003?
Give a very brief answer. 0.98. What is the difference between the highest and the second highest Number of teachers of Botswana?
Your response must be concise. 147. What is the difference between the highest and the second highest Number of teachers in Chad?
Ensure brevity in your answer.  171. What is the difference between the highest and the second highest Number of teachers of Korea (Republic)?
Make the answer very short. 2257. What is the difference between the highest and the second highest Number of teachers in Luxembourg?
Offer a very short reply. 73. What is the difference between the highest and the lowest Number of teachers of Botswana?
Make the answer very short. 5354. What is the difference between the highest and the lowest Number of teachers of Chad?
Provide a succinct answer. 1.14e+04. What is the difference between the highest and the lowest Number of teachers of Korea (Republic)?
Provide a short and direct response. 1.23e+04. What is the difference between the highest and the lowest Number of teachers in Luxembourg?
Make the answer very short. 1221. 